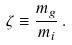<formula> <loc_0><loc_0><loc_500><loc_500>\zeta \equiv \frac { m _ { g } } { m _ { i } } \, .</formula> 